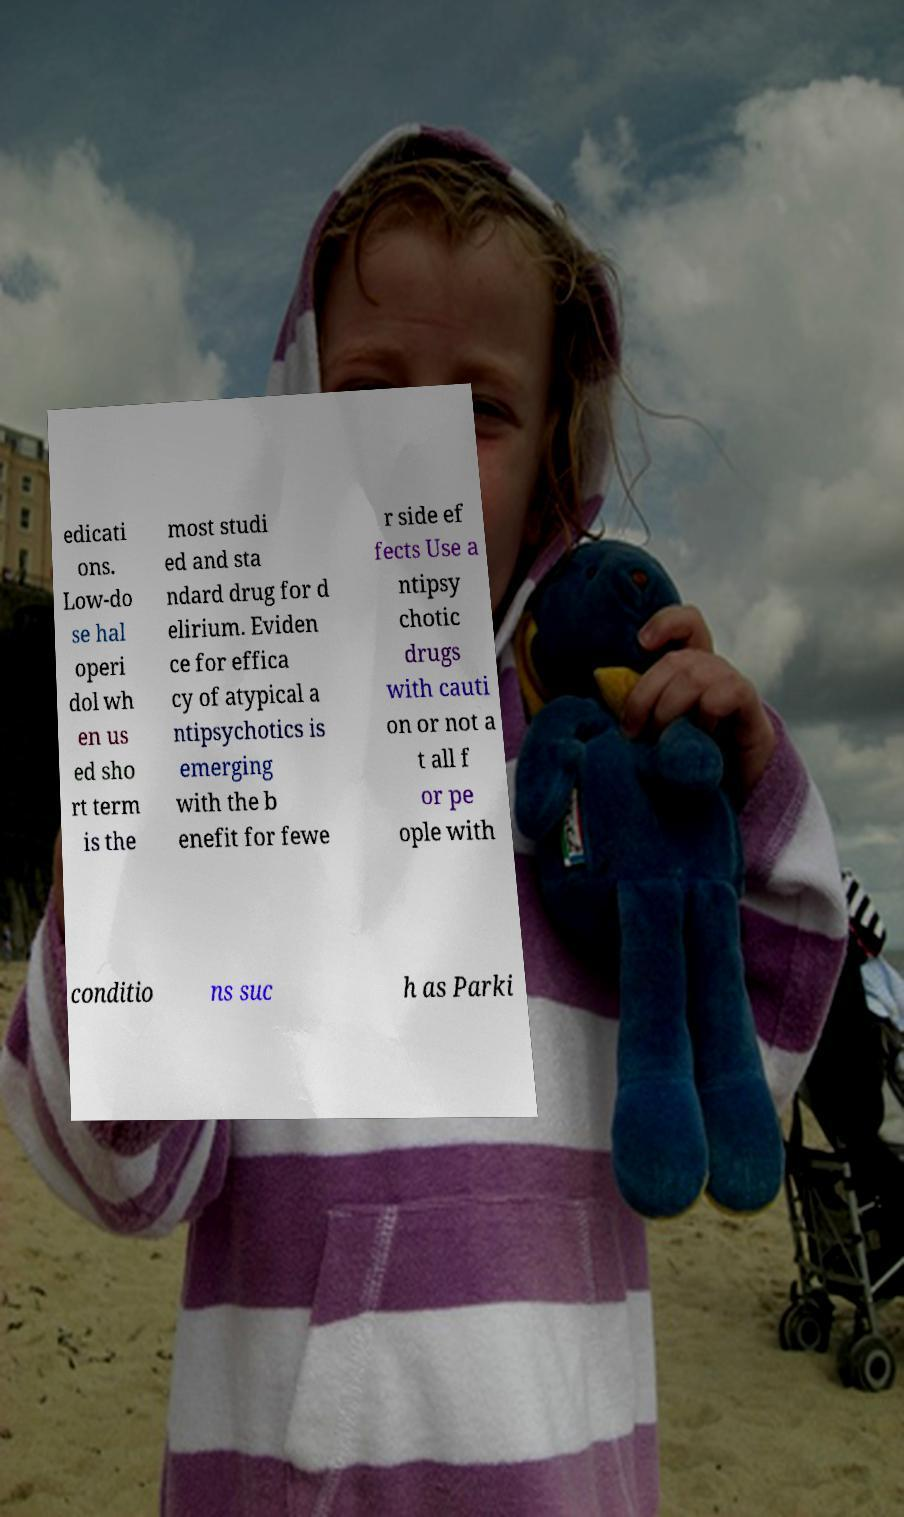Can you accurately transcribe the text from the provided image for me? edicati ons. Low-do se hal operi dol wh en us ed sho rt term is the most studi ed and sta ndard drug for d elirium. Eviden ce for effica cy of atypical a ntipsychotics is emerging with the b enefit for fewe r side ef fects Use a ntipsy chotic drugs with cauti on or not a t all f or pe ople with conditio ns suc h as Parki 